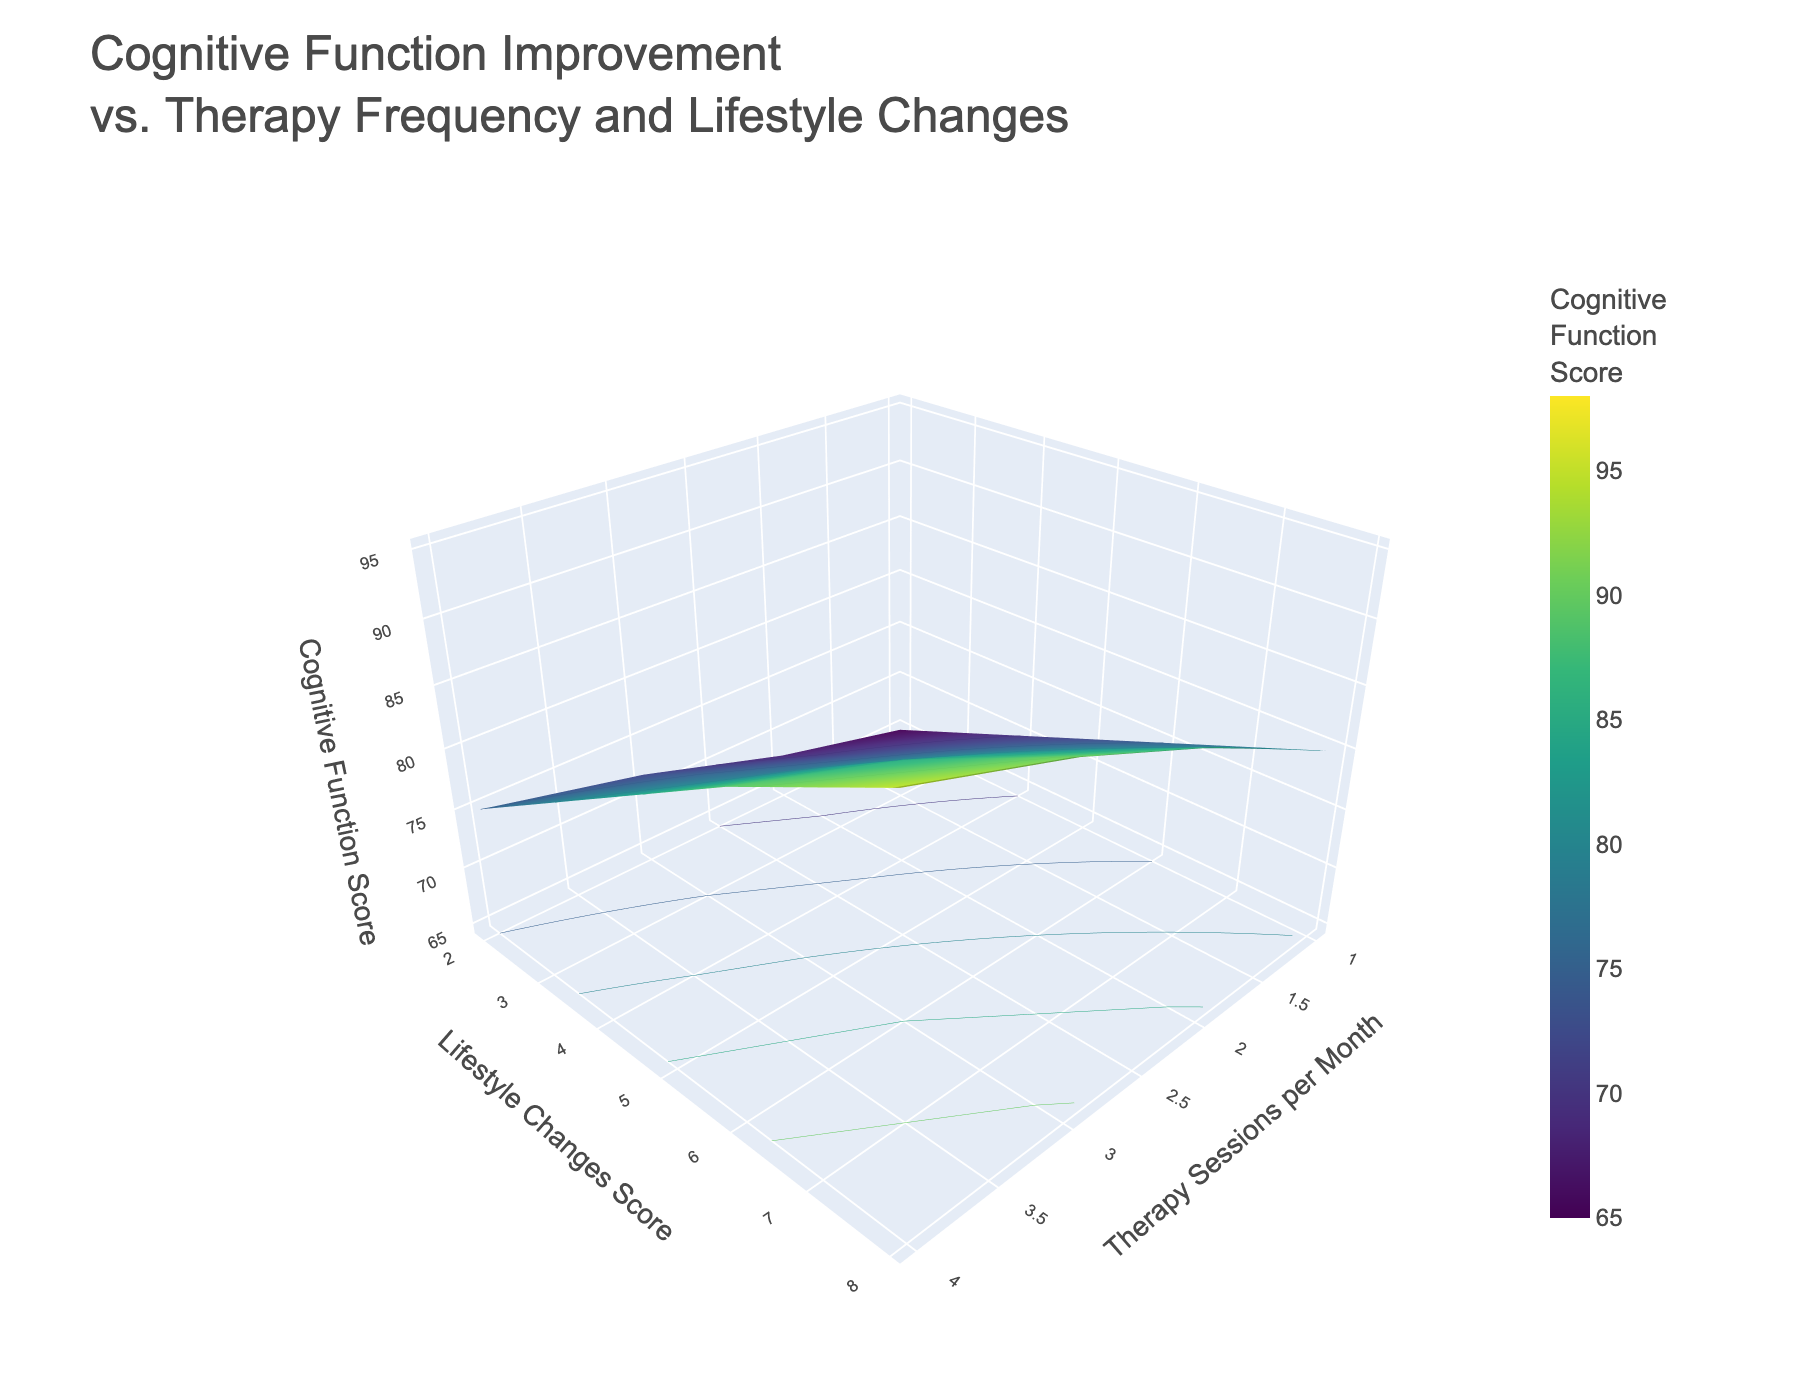What's the title of the plot? The title of the plot is displayed at the top and summarizes the figure's purpose. Here, it reads "Cognitive Function Improvement vs. Therapy Frequency and Lifestyle Changes".
Answer: Cognitive Function Improvement vs. Therapy Frequency and Lifestyle Changes What is the range of the Lifestyle Changes Score on the y-axis? The y-axis label is "Lifestyle Changes Score". The ticks on this axis show the scores range from 2 to 8.
Answer: 2 to 8 How does cognitive function change as therapy sessions per month increase from 1 to 5, given a constant lifestyle score of 6? Observing the surface plot's z-values along the line where x = 6, cognitive function scores at each therapy frequency can be compared. The scores progressively increase from 72 to 95.
Answer: Increases Which combination of therapy sessions per month and lifestyle changes score results in the highest cognitive function score? By looking at the peak values on the surface, we identify the highest z-value. The highest cognitive function score of 98 happens at 5 therapy sessions per month and a lifestyle score of 8.
Answer: 5 therapy sessions per month and a lifestyle score of 8 If a patient attends therapy 3 times per month, how does their cognitive function improve as their lifestyle changes score increases from 2 to 8? Analyzing the slice where x = 3 across varying y-values (2 to 8), the corresponding z-values (cognitive function scores) range from 75 to 89, showing improvement with higher lifestyle scores.
Answer: Improves from 75 to 89 Is there a clear relationship between lifestyle changes score and cognitive function score? Observing the surface, cognitive function scores tend to increase as lifestyle changes scores increase, indicating a positive correlation.
Answer: Positive correlation Between lifestyle changes scores of 4 and 6, which specific combination with any therapy frequency results in a cognitive function score above 85? Reviewing the z-values for y = 4 and y = 6, cognitive scores exceeding 85 occur at y = 4 with x = 4, 5; and y = 6 with x = 3, 4, 5.
Answer: 4 therapy sessions per month, 5 therapy sessions per month, 3 therapy sessions per month, 4 therapy sessions per month, 5 therapy sessions per month When therapy frequency is increased from 2 to 4 sessions per month, what is the average increase in cognitive function at a lifestyle score of 6? Calculate the difference in cognitive function for 2 sessions per month (78) and 4 sessions per month (91), then find the average increase: (91 - 78) = 13.
Answer: 13 How does cognitive function score change as both therapy sessions and lifestyle changes increase proportionally from low to high? Visual scanning of the surface plot reveals that moving diagonally from the origin towards the top right enhances both therapy sessions and lifestyle changes, leading to a consistent cognitive function improvement.
Answer: It improves consistently 